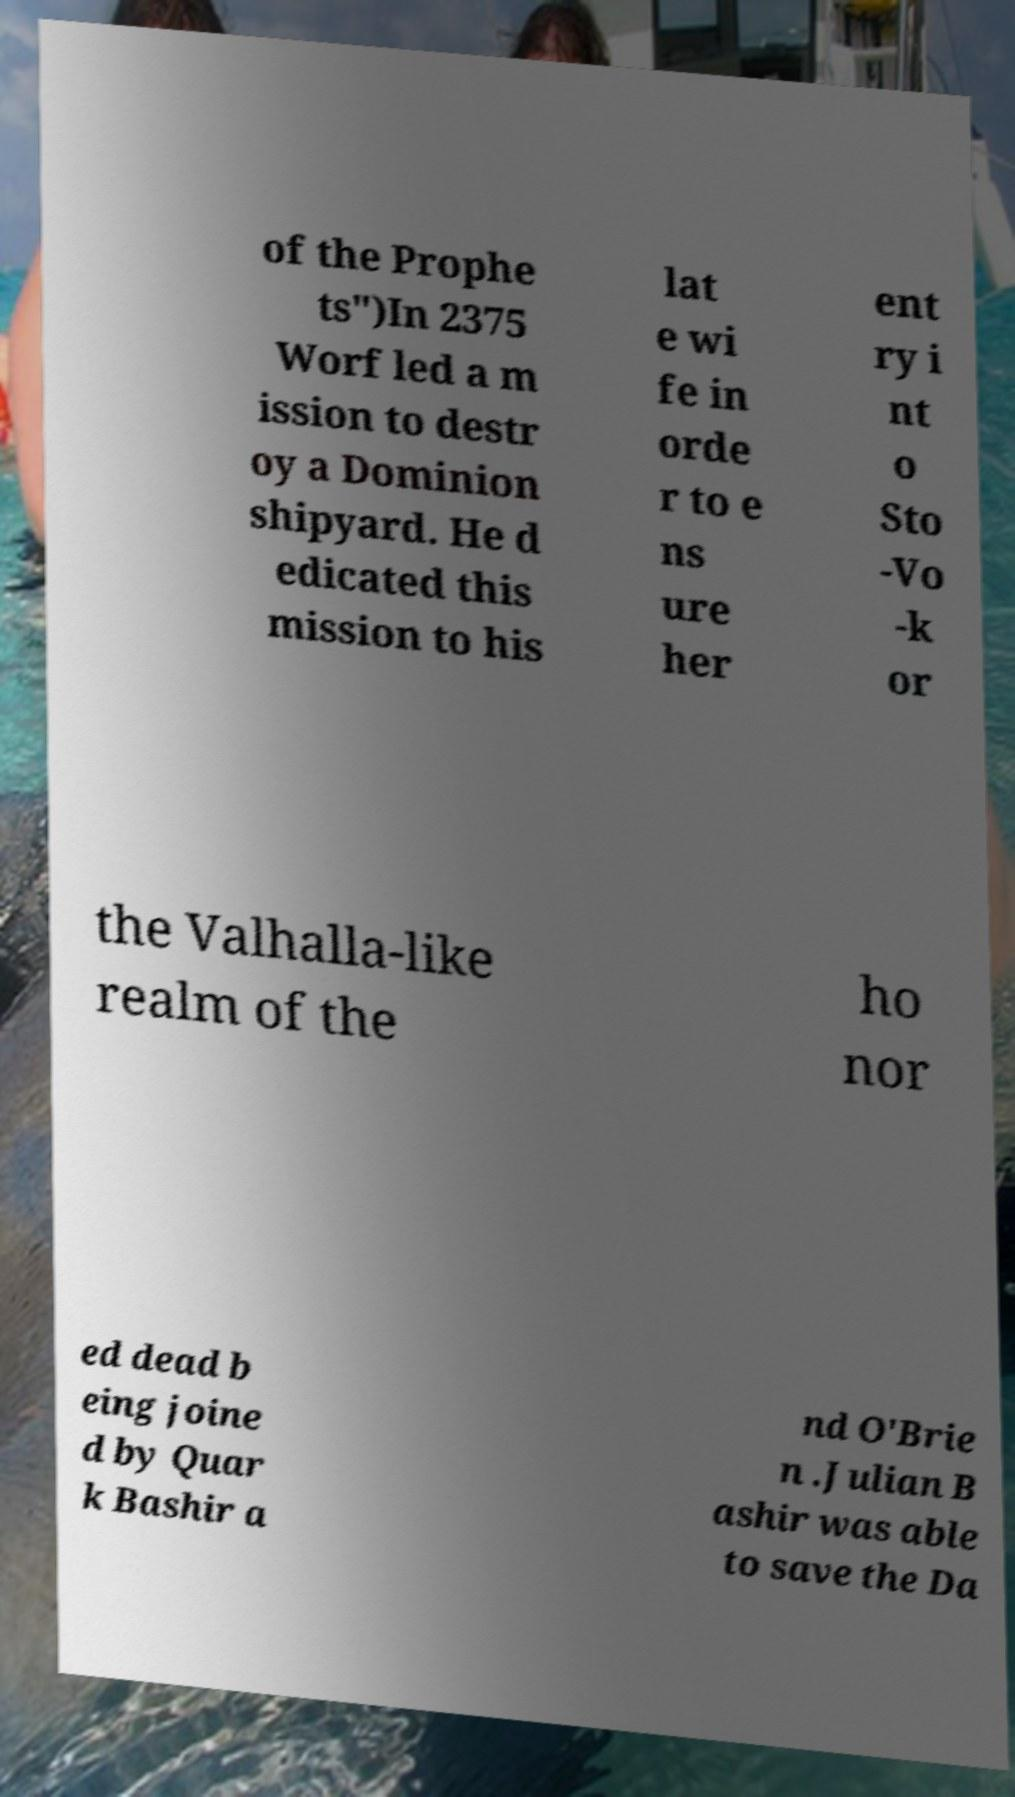For documentation purposes, I need the text within this image transcribed. Could you provide that? of the Prophe ts")In 2375 Worf led a m ission to destr oy a Dominion shipyard. He d edicated this mission to his lat e wi fe in orde r to e ns ure her ent ry i nt o Sto -Vo -k or the Valhalla-like realm of the ho nor ed dead b eing joine d by Quar k Bashir a nd O'Brie n .Julian B ashir was able to save the Da 